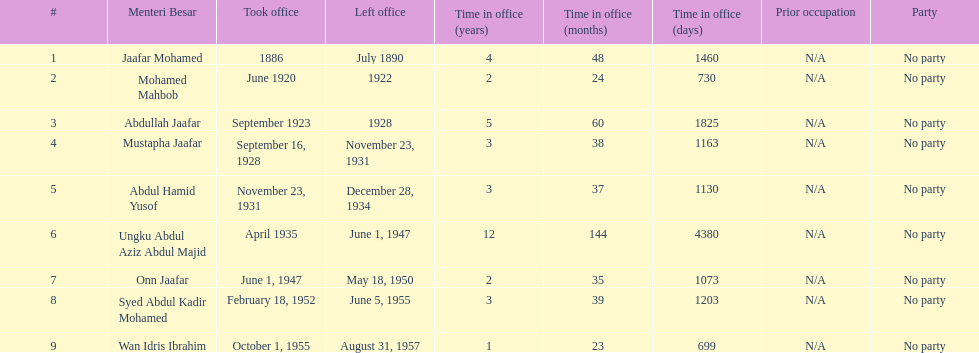Who spend the most amount of time in office? Ungku Abdul Aziz Abdul Majid. 